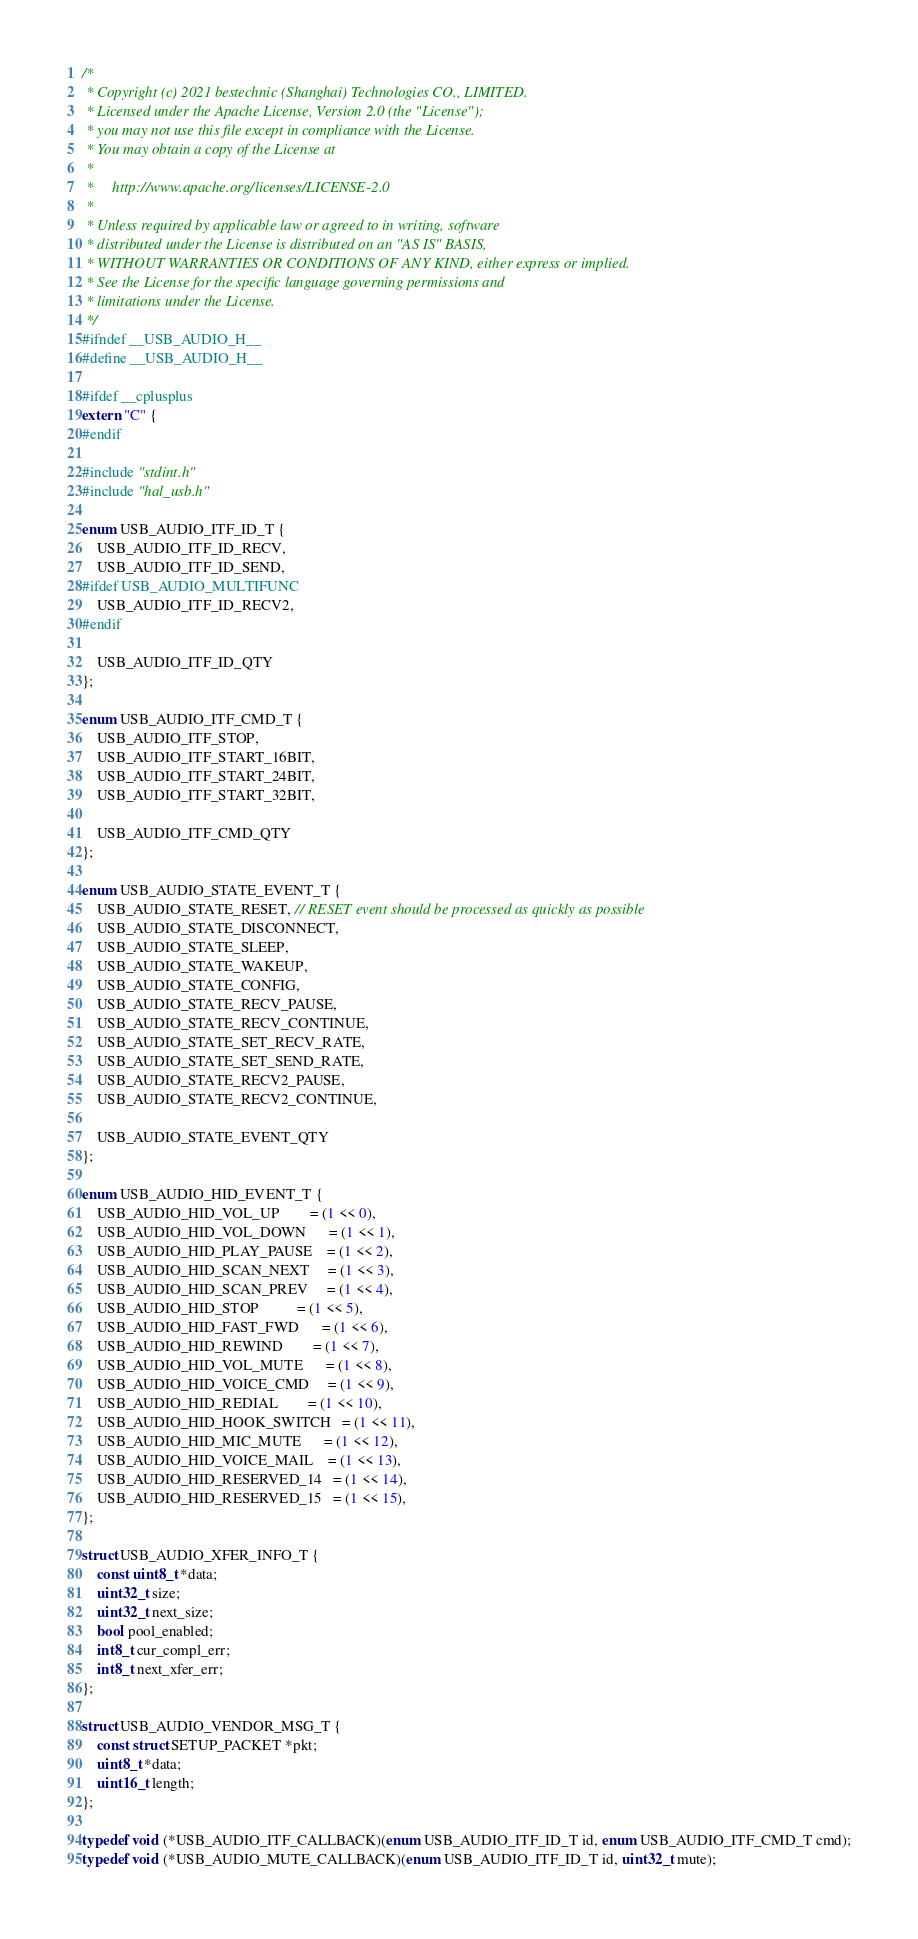<code> <loc_0><loc_0><loc_500><loc_500><_C_>/*
 * Copyright (c) 2021 bestechnic (Shanghai) Technologies CO., LIMITED.
 * Licensed under the Apache License, Version 2.0 (the "License");
 * you may not use this file except in compliance with the License.
 * You may obtain a copy of the License at
 *
 *     http://www.apache.org/licenses/LICENSE-2.0
 *
 * Unless required by applicable law or agreed to in writing, software
 * distributed under the License is distributed on an "AS IS" BASIS,
 * WITHOUT WARRANTIES OR CONDITIONS OF ANY KIND, either express or implied.
 * See the License for the specific language governing permissions and
 * limitations under the License.
 */
#ifndef __USB_AUDIO_H__
#define __USB_AUDIO_H__

#ifdef __cplusplus
extern "C" {
#endif

#include "stdint.h"
#include "hal_usb.h"

enum USB_AUDIO_ITF_ID_T {
    USB_AUDIO_ITF_ID_RECV,
    USB_AUDIO_ITF_ID_SEND,
#ifdef USB_AUDIO_MULTIFUNC
    USB_AUDIO_ITF_ID_RECV2,
#endif

    USB_AUDIO_ITF_ID_QTY
};

enum USB_AUDIO_ITF_CMD_T {
    USB_AUDIO_ITF_STOP,
    USB_AUDIO_ITF_START_16BIT,
    USB_AUDIO_ITF_START_24BIT,
    USB_AUDIO_ITF_START_32BIT,

    USB_AUDIO_ITF_CMD_QTY
};

enum USB_AUDIO_STATE_EVENT_T {
    USB_AUDIO_STATE_RESET, // RESET event should be processed as quickly as possible
    USB_AUDIO_STATE_DISCONNECT,
    USB_AUDIO_STATE_SLEEP,
    USB_AUDIO_STATE_WAKEUP,
    USB_AUDIO_STATE_CONFIG,
    USB_AUDIO_STATE_RECV_PAUSE,
    USB_AUDIO_STATE_RECV_CONTINUE,
    USB_AUDIO_STATE_SET_RECV_RATE,
    USB_AUDIO_STATE_SET_SEND_RATE,
    USB_AUDIO_STATE_RECV2_PAUSE,
    USB_AUDIO_STATE_RECV2_CONTINUE,

    USB_AUDIO_STATE_EVENT_QTY
};

enum USB_AUDIO_HID_EVENT_T {
    USB_AUDIO_HID_VOL_UP        = (1 << 0),
    USB_AUDIO_HID_VOL_DOWN      = (1 << 1),
    USB_AUDIO_HID_PLAY_PAUSE    = (1 << 2),
    USB_AUDIO_HID_SCAN_NEXT     = (1 << 3),
    USB_AUDIO_HID_SCAN_PREV     = (1 << 4),
    USB_AUDIO_HID_STOP          = (1 << 5),
    USB_AUDIO_HID_FAST_FWD      = (1 << 6),
    USB_AUDIO_HID_REWIND        = (1 << 7),
    USB_AUDIO_HID_VOL_MUTE      = (1 << 8),
    USB_AUDIO_HID_VOICE_CMD     = (1 << 9),
    USB_AUDIO_HID_REDIAL        = (1 << 10),
    USB_AUDIO_HID_HOOK_SWITCH   = (1 << 11),
    USB_AUDIO_HID_MIC_MUTE      = (1 << 12),
    USB_AUDIO_HID_VOICE_MAIL    = (1 << 13),
    USB_AUDIO_HID_RESERVED_14   = (1 << 14),
    USB_AUDIO_HID_RESERVED_15   = (1 << 15),
};

struct USB_AUDIO_XFER_INFO_T {
    const uint8_t *data;
    uint32_t size;
    uint32_t next_size;
    bool pool_enabled;
    int8_t cur_compl_err;
    int8_t next_xfer_err;
};

struct USB_AUDIO_VENDOR_MSG_T {
    const struct SETUP_PACKET *pkt;
    uint8_t *data;
    uint16_t length;
};

typedef void (*USB_AUDIO_ITF_CALLBACK)(enum USB_AUDIO_ITF_ID_T id, enum USB_AUDIO_ITF_CMD_T cmd);
typedef void (*USB_AUDIO_MUTE_CALLBACK)(enum USB_AUDIO_ITF_ID_T id, uint32_t mute);</code> 